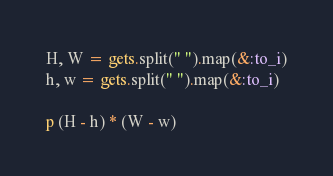<code> <loc_0><loc_0><loc_500><loc_500><_Ruby_>H, W = gets.split(" ").map(&:to_i)
h, w = gets.split(" ").map(&:to_i)

p (H - h) * (W - w)</code> 